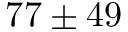Convert formula to latex. <formula><loc_0><loc_0><loc_500><loc_500>7 7 \pm 4 9</formula> 